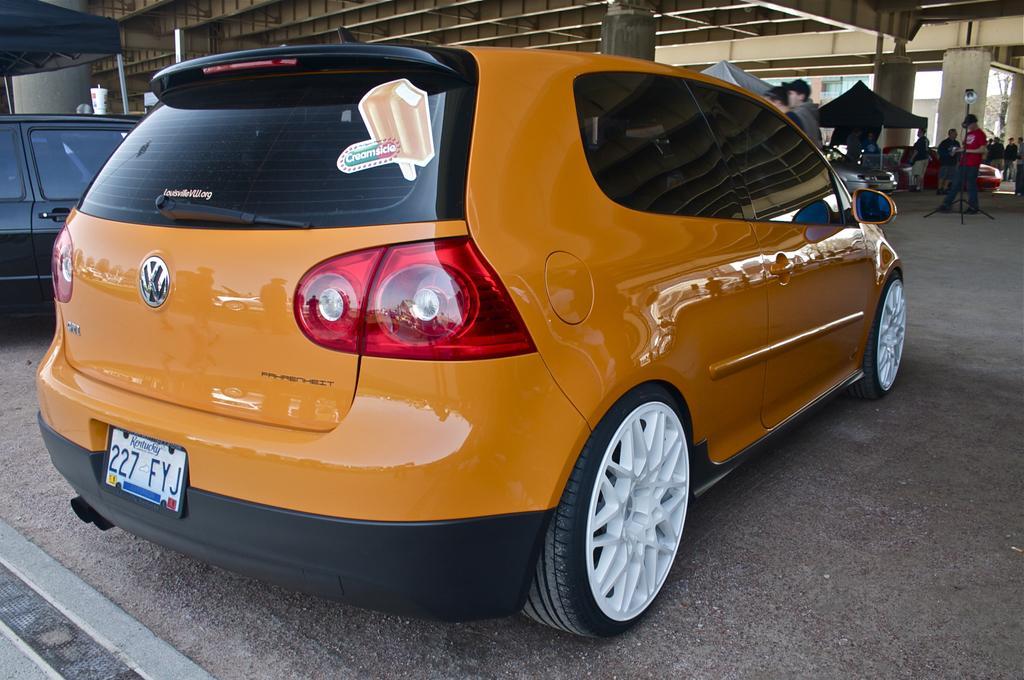Describe this image in one or two sentences. In this image there are few cars parked, in front of them there are a few people standing, there are few objects and pillars. At the top of the image there is a ceiling. 